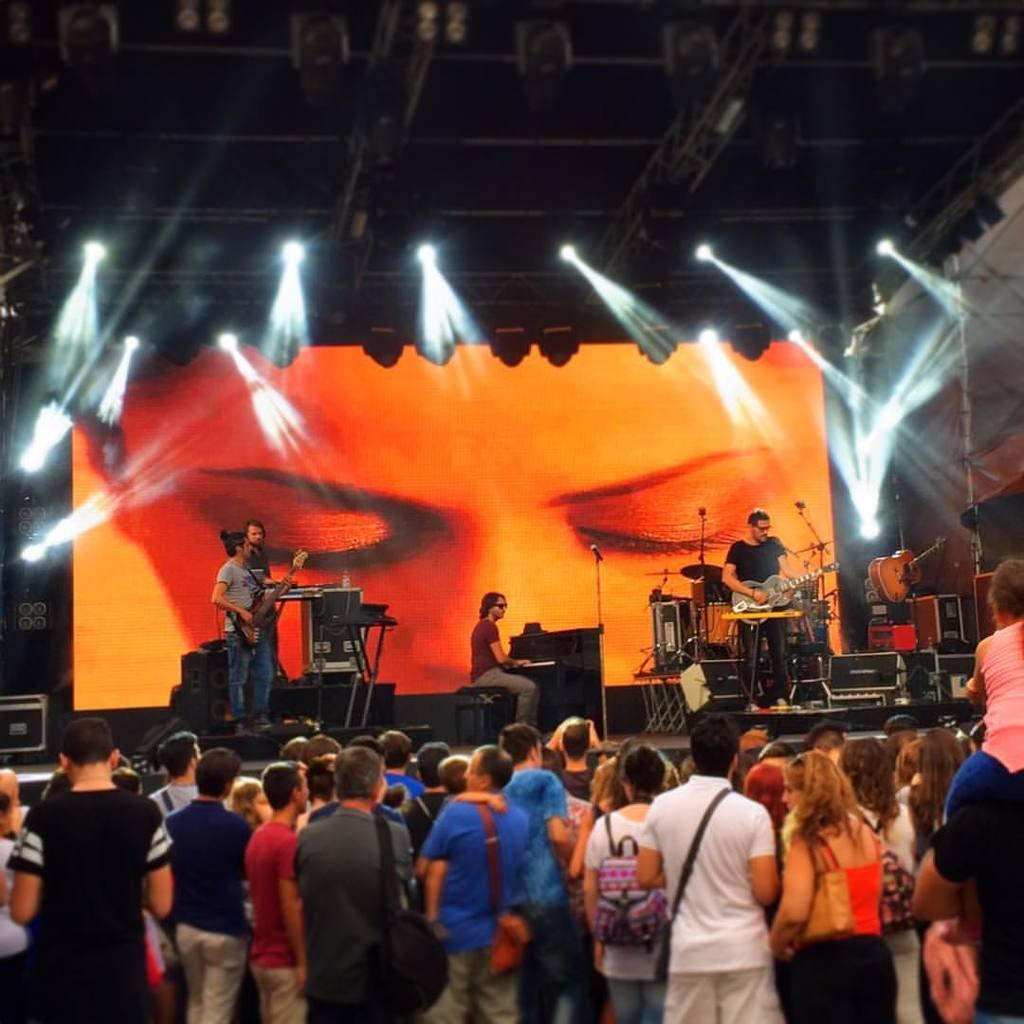Could you give a brief overview of what you see in this image? In this image i can see group of people at the back i can see four men few are standing and this man is sitting and playing the musical instrument. At the background i can see a screen, at the i can see few lights. 